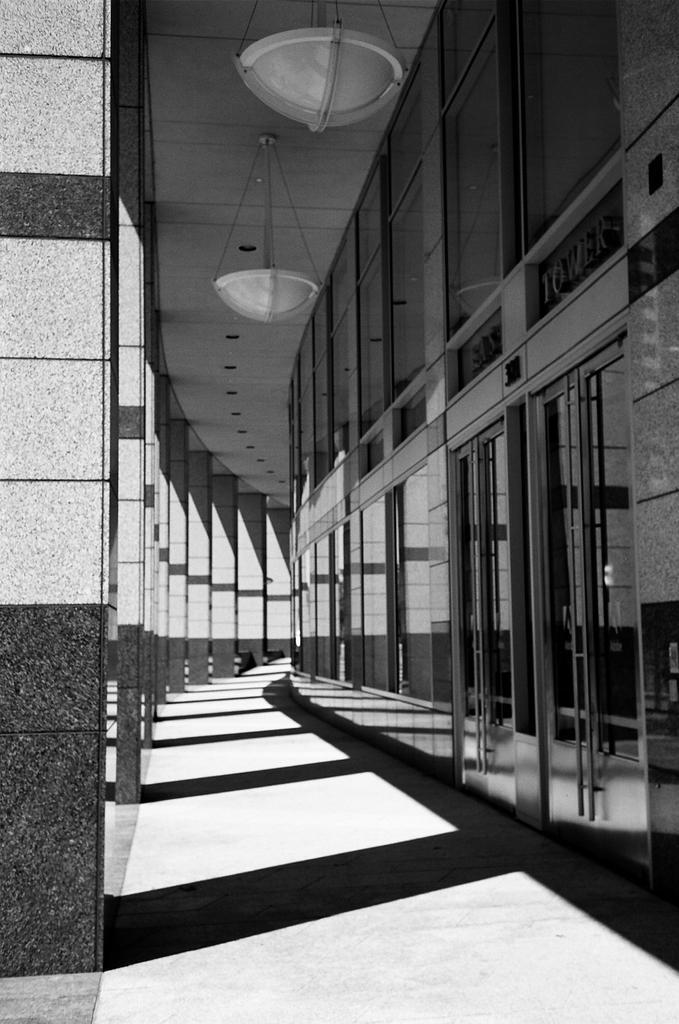Could you give a brief overview of what you see in this image? This is a black and white image. On the left side there are pillars. Also there are glass walls. On the ceiling there are objects hung. 